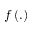Convert formula to latex. <formula><loc_0><loc_0><loc_500><loc_500>f \left ( . \right )</formula> 